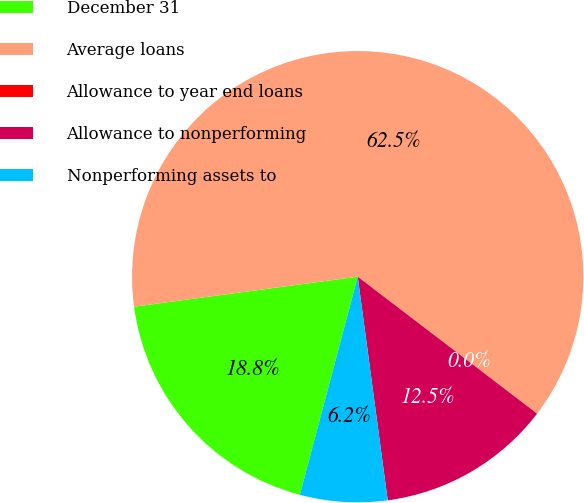Convert chart to OTSL. <chart><loc_0><loc_0><loc_500><loc_500><pie_chart><fcel>December 31<fcel>Average loans<fcel>Allowance to year end loans<fcel>Allowance to nonperforming<fcel>Nonperforming assets to<nl><fcel>18.75%<fcel>62.5%<fcel>0.0%<fcel>12.5%<fcel>6.25%<nl></chart> 